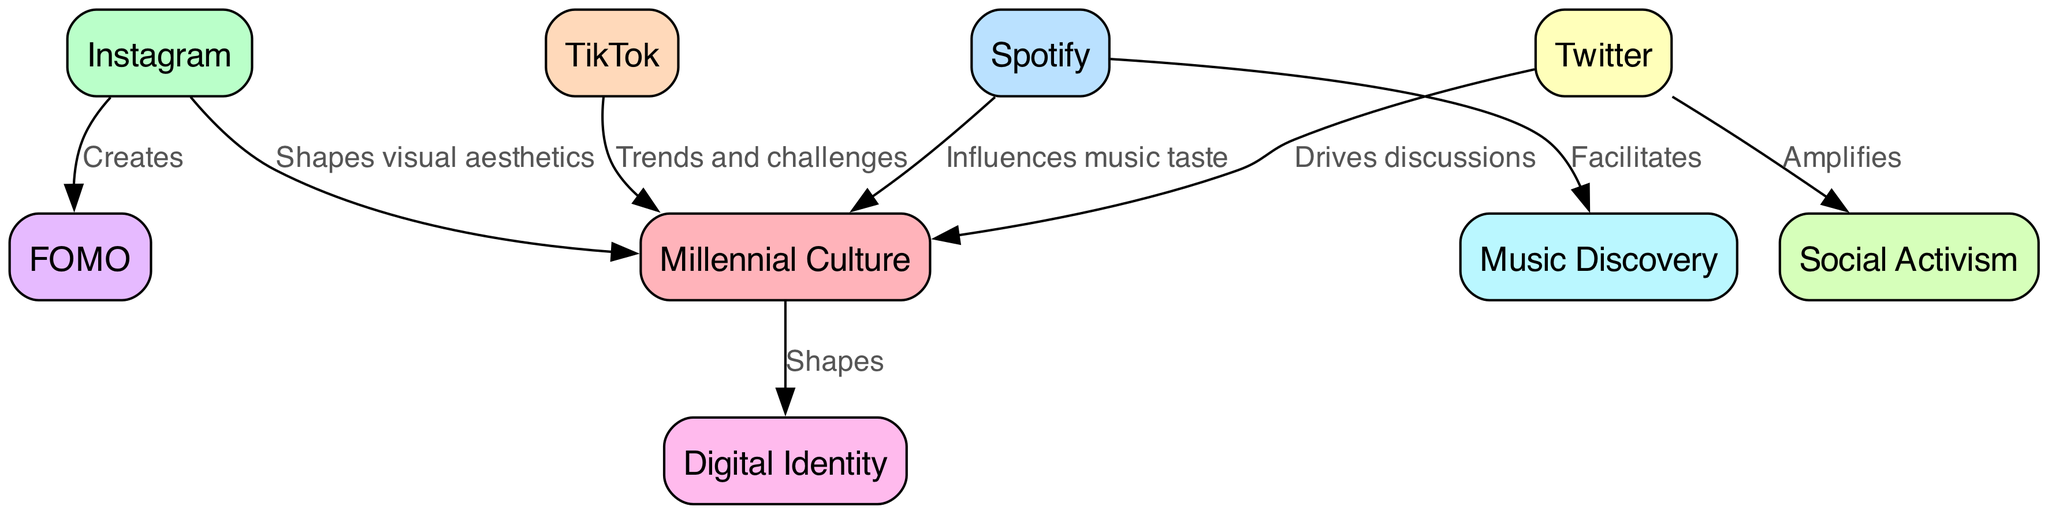What are the total number of nodes in the diagram? The diagram lists 8 unique nodes, each representing a concept related to millennial culture and social media platforms. Counting each node gives a total of 8.
Answer: 8 Which platform influences music taste? The diagram clearly indicates that Spotify is connected to millennial culture with the label "Influences music taste," showing its role in shaping music preferences among millennials.
Answer: Spotify What does Instagram create related to FOMO? The diagram shows a direct edge from Instagram to FOMO labeled "Creates," indicating that Instagram is responsible for generating the Fear of Missing Out (FOMO) phenomenon.
Answer: Creates How many platforms drive discussions in millennial culture? According to the diagram, only one platform, Twitter, drives discussions as indicated by the edge labeled "Drives discussions." Thus, the answer is 1.
Answer: 1 What is the relationship between Twitter and social activism? The edge from Twitter to social activism is labeled "Amplifies," indicating that Twitter enhances or increases the presence of social activism in millennial culture.
Answer: Amplifies Which platform connects to music discovery? The diagram shows that the edge from Spotify connects to music discovery with the label "Facilitates," highlighting Spotify's role in helping users discover new music.
Answer: Facilitates How does millennial culture shape digital identity? The diagram has an edge from millennial culture to digital identity labeled "Shapes," meaning that the overall cultural aspects of millennials influence or mold their digital representations.
Answer: Shapes What type of cultural aspect does TikTok influence? The diagram indicates a relationship between TikTok and millennial culture through trends and challenges, thus TikTok influences cultural dynamics by introducing viral trends and challenges.
Answer: Trends and challenges 